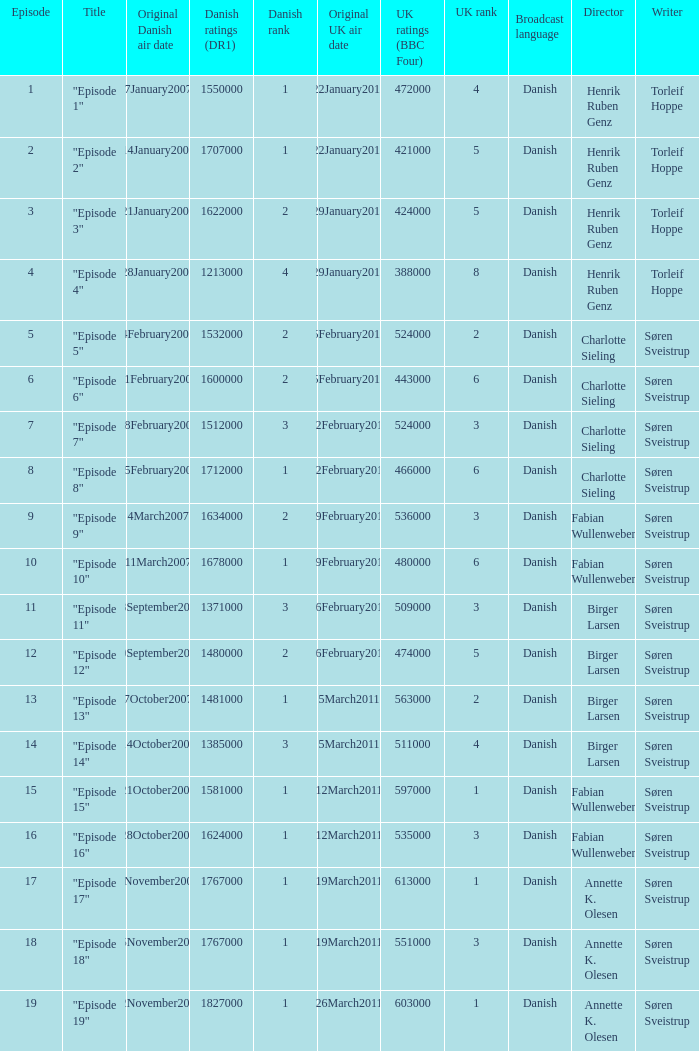What is the original Danish air date of "Episode 17"?  8November2007. 